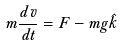Convert formula to latex. <formula><loc_0><loc_0><loc_500><loc_500>m \frac { d \vec { v } } { d t } = \vec { F } - m g \hat { k }</formula> 